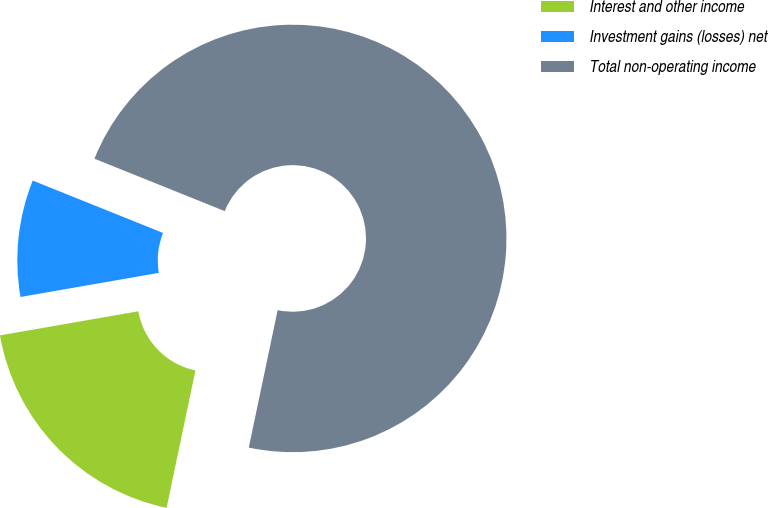Convert chart. <chart><loc_0><loc_0><loc_500><loc_500><pie_chart><fcel>Interest and other income<fcel>Investment gains (losses) net<fcel>Total non-operating income<nl><fcel>18.96%<fcel>8.83%<fcel>72.21%<nl></chart> 